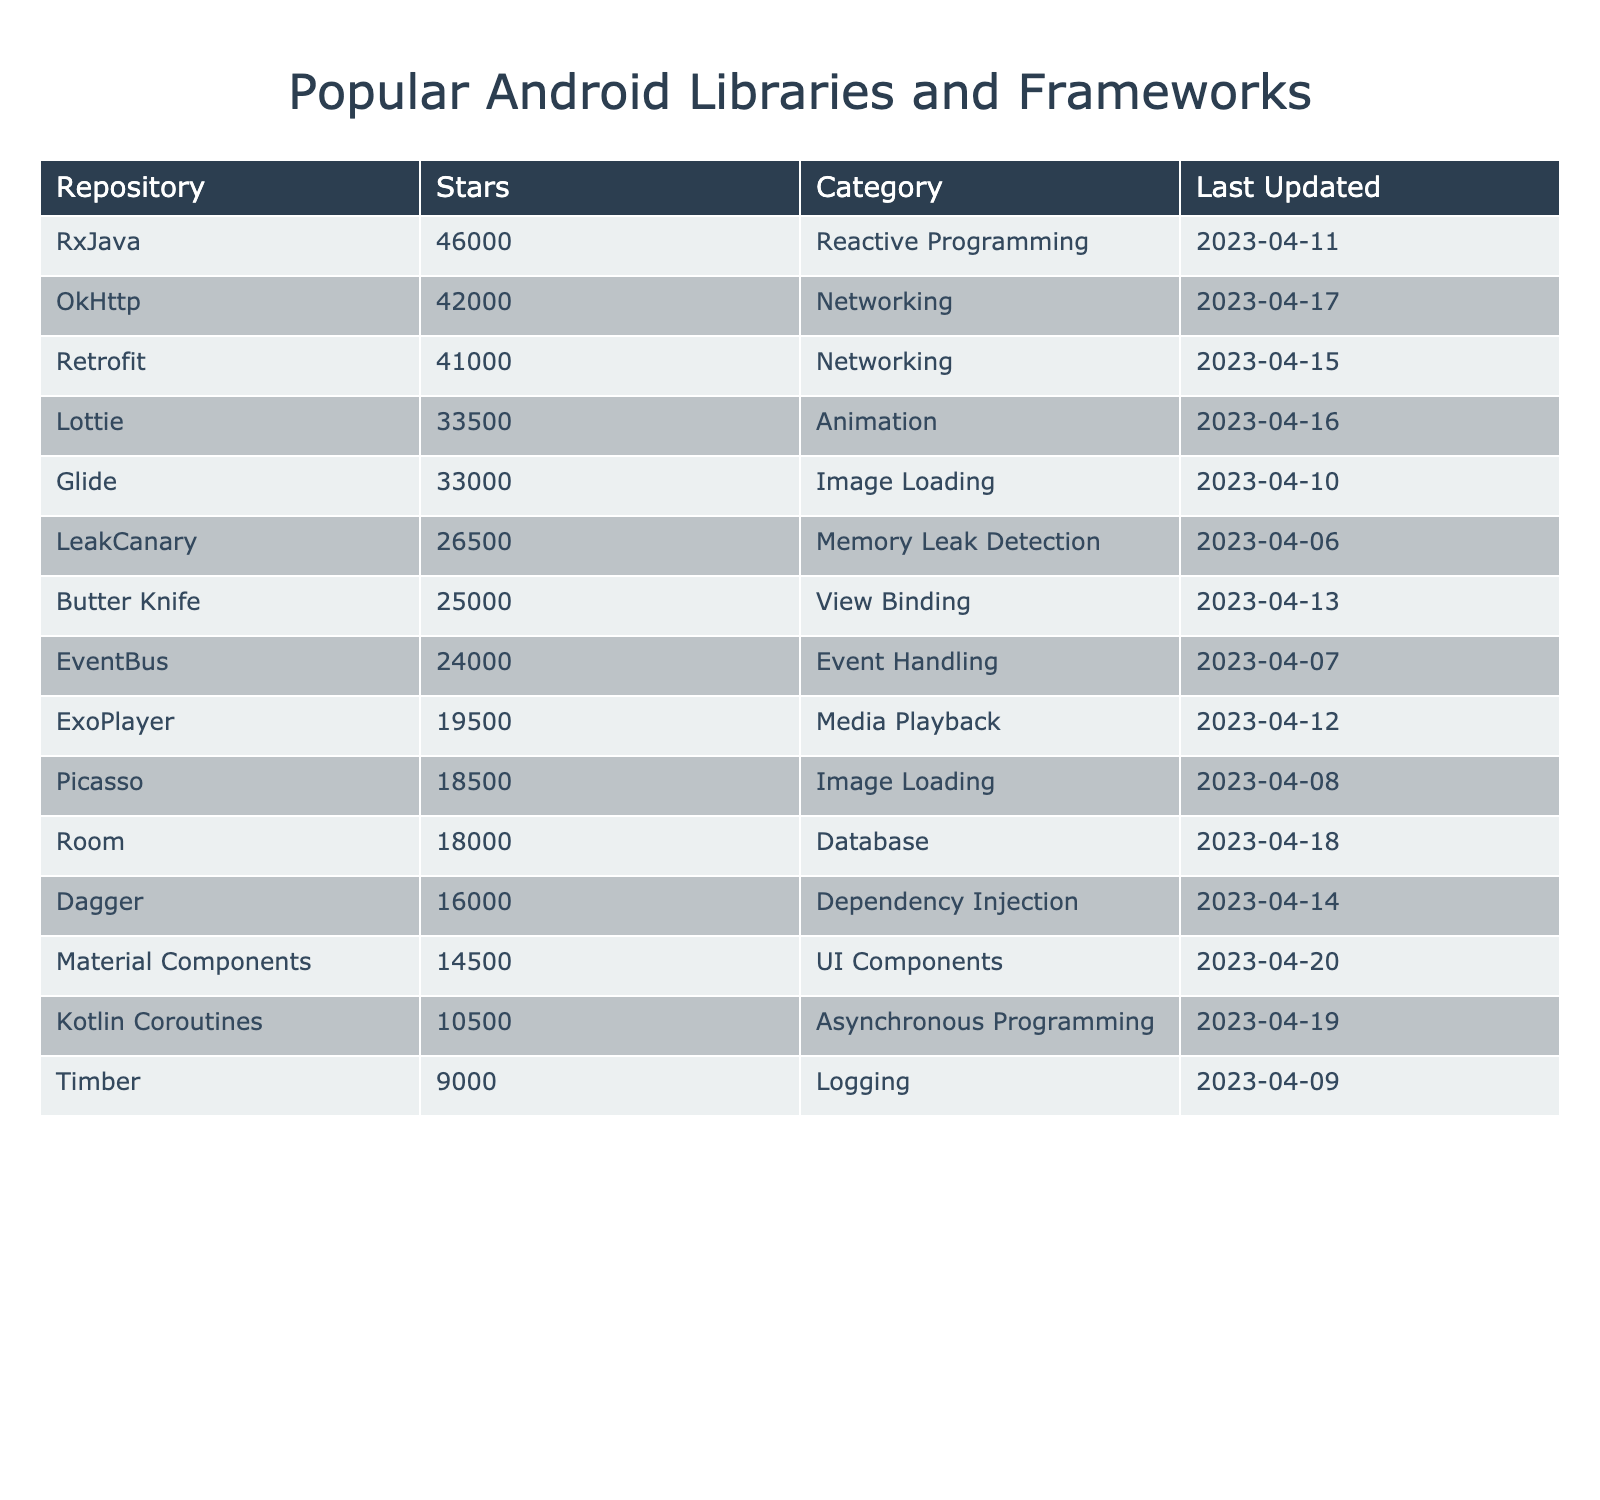What is the most starred repository in the table? By looking at the "Stars" column, we can see that the repository with the highest star count is "RxJava" with 46,000 stars.
Answer: 46,000 stars How many stars does the "Glide" repository have? The "Glide" repository has 33,000 stars as can be found directly in the "Stars" column.
Answer: 33,000 stars Which repository belongs to the "Database" category? According to the "Category" column, the "Room" repository is categorized under "Database."
Answer: Room What is the average number of stars for all repositories listed in the table? To calculate the average, we add up the stars: (41000 + 33000 + 18000 + 19500 + 16000 + 46000 + 9000 + 25000 + 33500 + 18500 + 42000 + 24000 + 10500 + 14500 + 26500) = 332500. There are 15 repositories, so the average stars = 332500 / 15 ≈ 22166.67.
Answer: ≈ 22167 stars Which libraries have more than 30,000 stars? By reviewing the "Stars" column, we can identify the repositories: "RxJava," "OkHttp," "Retrofit," "Lottie," and "Glide" all have more than 30,000 stars.
Answer: RxJava, OkHttp, Retrofit, Lottie, Glide Is "Timber" the most recently updated repository? Checking the "Last Updated" column, "Timber" was last updated on 2023-04-09, which is earlier than some others like "Room" (2023-04-18), "Lottie" (2023-04-16), and "Kotlin Coroutines" (2023-04-19). Therefore, "Timber" is not the most recent update.
Answer: No What is the difference in the number of stars between "LeakCanary" and "Timber"? "LeakCanary" has 26,500 stars and "Timber" has 9,000 stars. The difference is 26500 - 9000 = 17500 stars.
Answer: 17,500 stars Which category has the least number of stars for its most starred library? "Logging" is the category with "Timber" (9000 stars), which is the least in comparison to other categories' top libraries.
Answer: Logging Determine the total number of stars for all Networking libraries combined. The "Networking" libraries are "OkHttp" (42000 stars) and "Retrofit" (41000 stars). Total stars = 42000 + 41000 = 83000.
Answer: 83,000 stars How many libraries are categorized under "Image Loading"? The "Image Loading" category has two libraries listed: "Glide" and "Picasso."
Answer: 2 libraries Are there any repositories in the "UI Components" category? Yes, the "Material Components" repository is categorized under "UI Components." This is confirmed by looking at the table's "Category" column.
Answer: Yes 